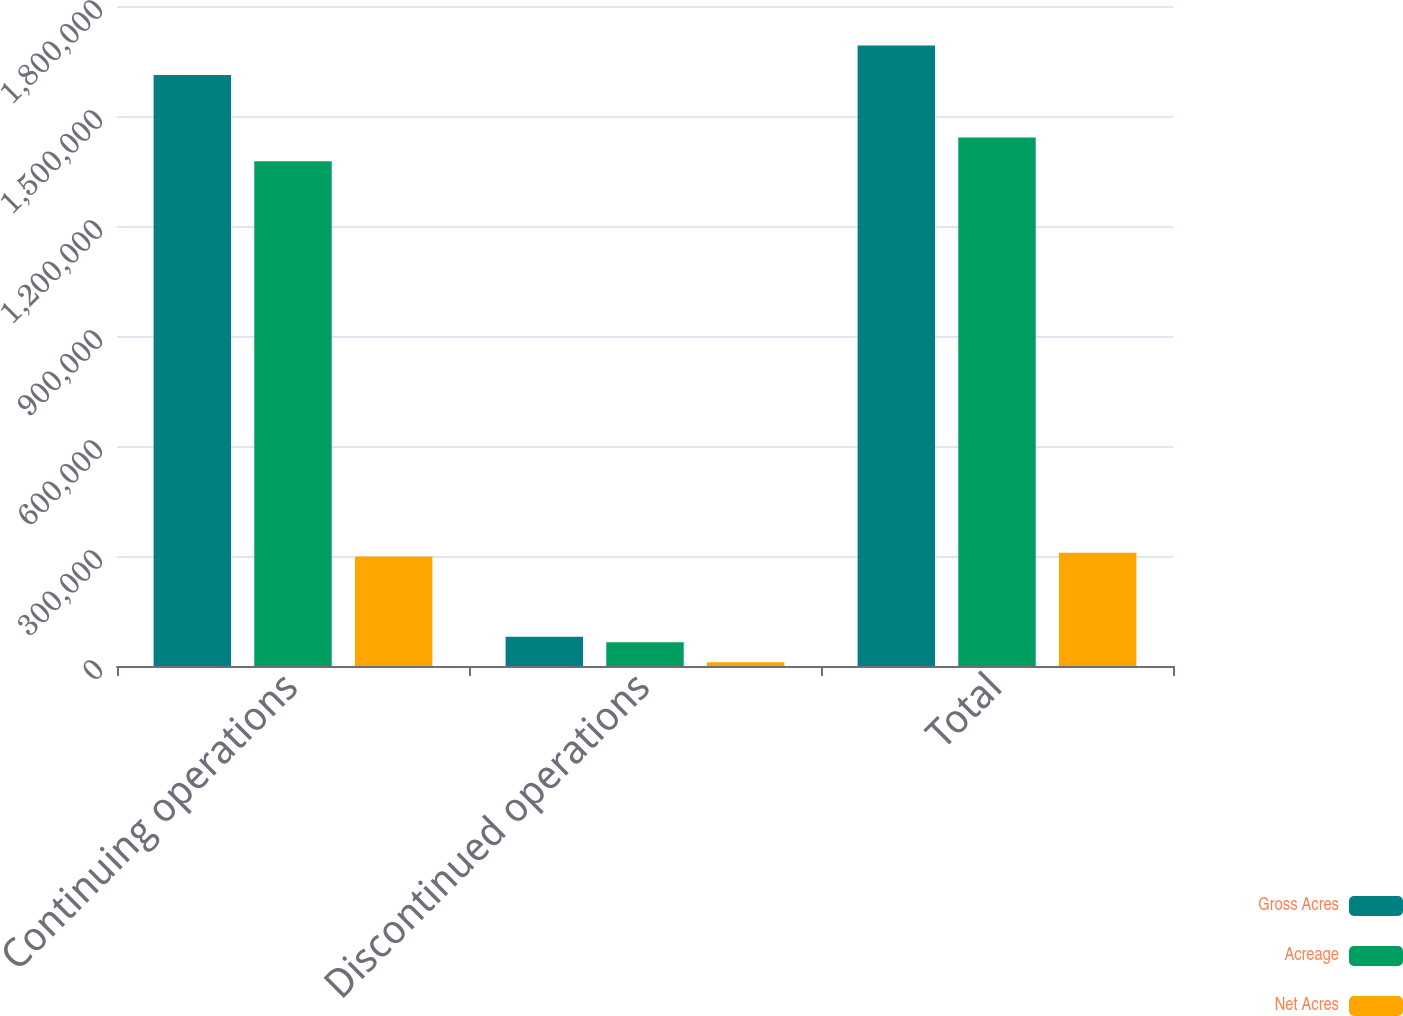Convert chart to OTSL. <chart><loc_0><loc_0><loc_500><loc_500><stacked_bar_chart><ecel><fcel>Continuing operations<fcel>Discontinued operations<fcel>Total<nl><fcel>Gross Acres<fcel>1.61206e+06<fcel>79953<fcel>1.69201e+06<nl><fcel>Acreage<fcel>1.37662e+06<fcel>64558<fcel>1.44117e+06<nl><fcel>Net Acres<fcel>298443<fcel>10497<fcel>308940<nl></chart> 